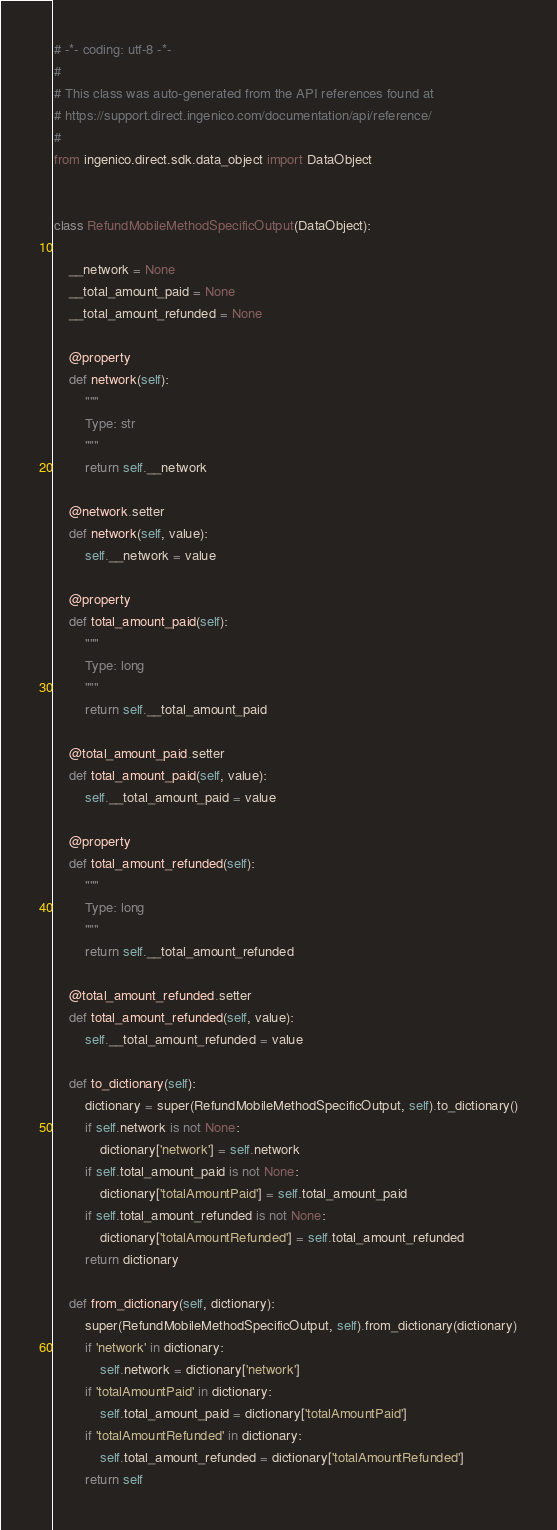Convert code to text. <code><loc_0><loc_0><loc_500><loc_500><_Python_># -*- coding: utf-8 -*-
#
# This class was auto-generated from the API references found at
# https://support.direct.ingenico.com/documentation/api/reference/
#
from ingenico.direct.sdk.data_object import DataObject


class RefundMobileMethodSpecificOutput(DataObject):

    __network = None
    __total_amount_paid = None
    __total_amount_refunded = None

    @property
    def network(self):
        """
        Type: str
        """
        return self.__network

    @network.setter
    def network(self, value):
        self.__network = value

    @property
    def total_amount_paid(self):
        """
        Type: long
        """
        return self.__total_amount_paid

    @total_amount_paid.setter
    def total_amount_paid(self, value):
        self.__total_amount_paid = value

    @property
    def total_amount_refunded(self):
        """
        Type: long
        """
        return self.__total_amount_refunded

    @total_amount_refunded.setter
    def total_amount_refunded(self, value):
        self.__total_amount_refunded = value

    def to_dictionary(self):
        dictionary = super(RefundMobileMethodSpecificOutput, self).to_dictionary()
        if self.network is not None:
            dictionary['network'] = self.network
        if self.total_amount_paid is not None:
            dictionary['totalAmountPaid'] = self.total_amount_paid
        if self.total_amount_refunded is not None:
            dictionary['totalAmountRefunded'] = self.total_amount_refunded
        return dictionary

    def from_dictionary(self, dictionary):
        super(RefundMobileMethodSpecificOutput, self).from_dictionary(dictionary)
        if 'network' in dictionary:
            self.network = dictionary['network']
        if 'totalAmountPaid' in dictionary:
            self.total_amount_paid = dictionary['totalAmountPaid']
        if 'totalAmountRefunded' in dictionary:
            self.total_amount_refunded = dictionary['totalAmountRefunded']
        return self
</code> 